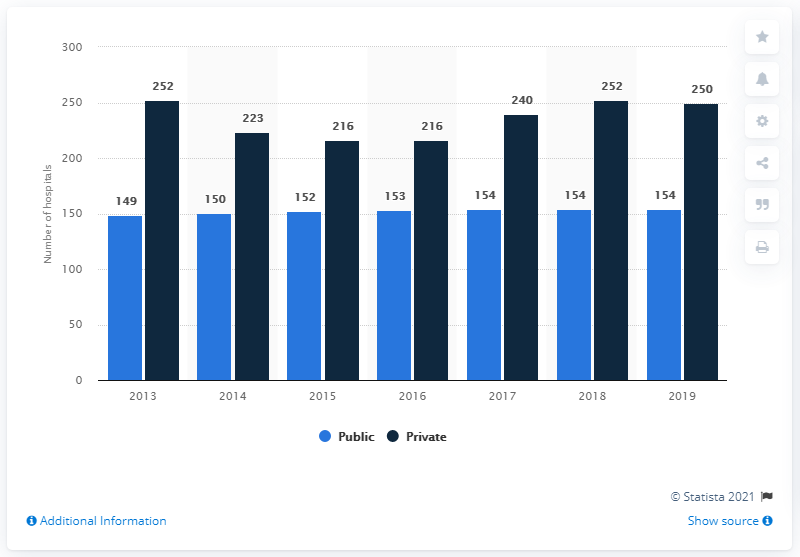List a handful of essential elements in this visual. In 2019, there were approximately 250 private hospitals in Malaysia. In 2013, there were the highest number of public hospitals. In 2019, there were 154 government hospitals in Malaysia. In 2019, the difference in the number of hospitals between those that were public and those that were private was 96. 